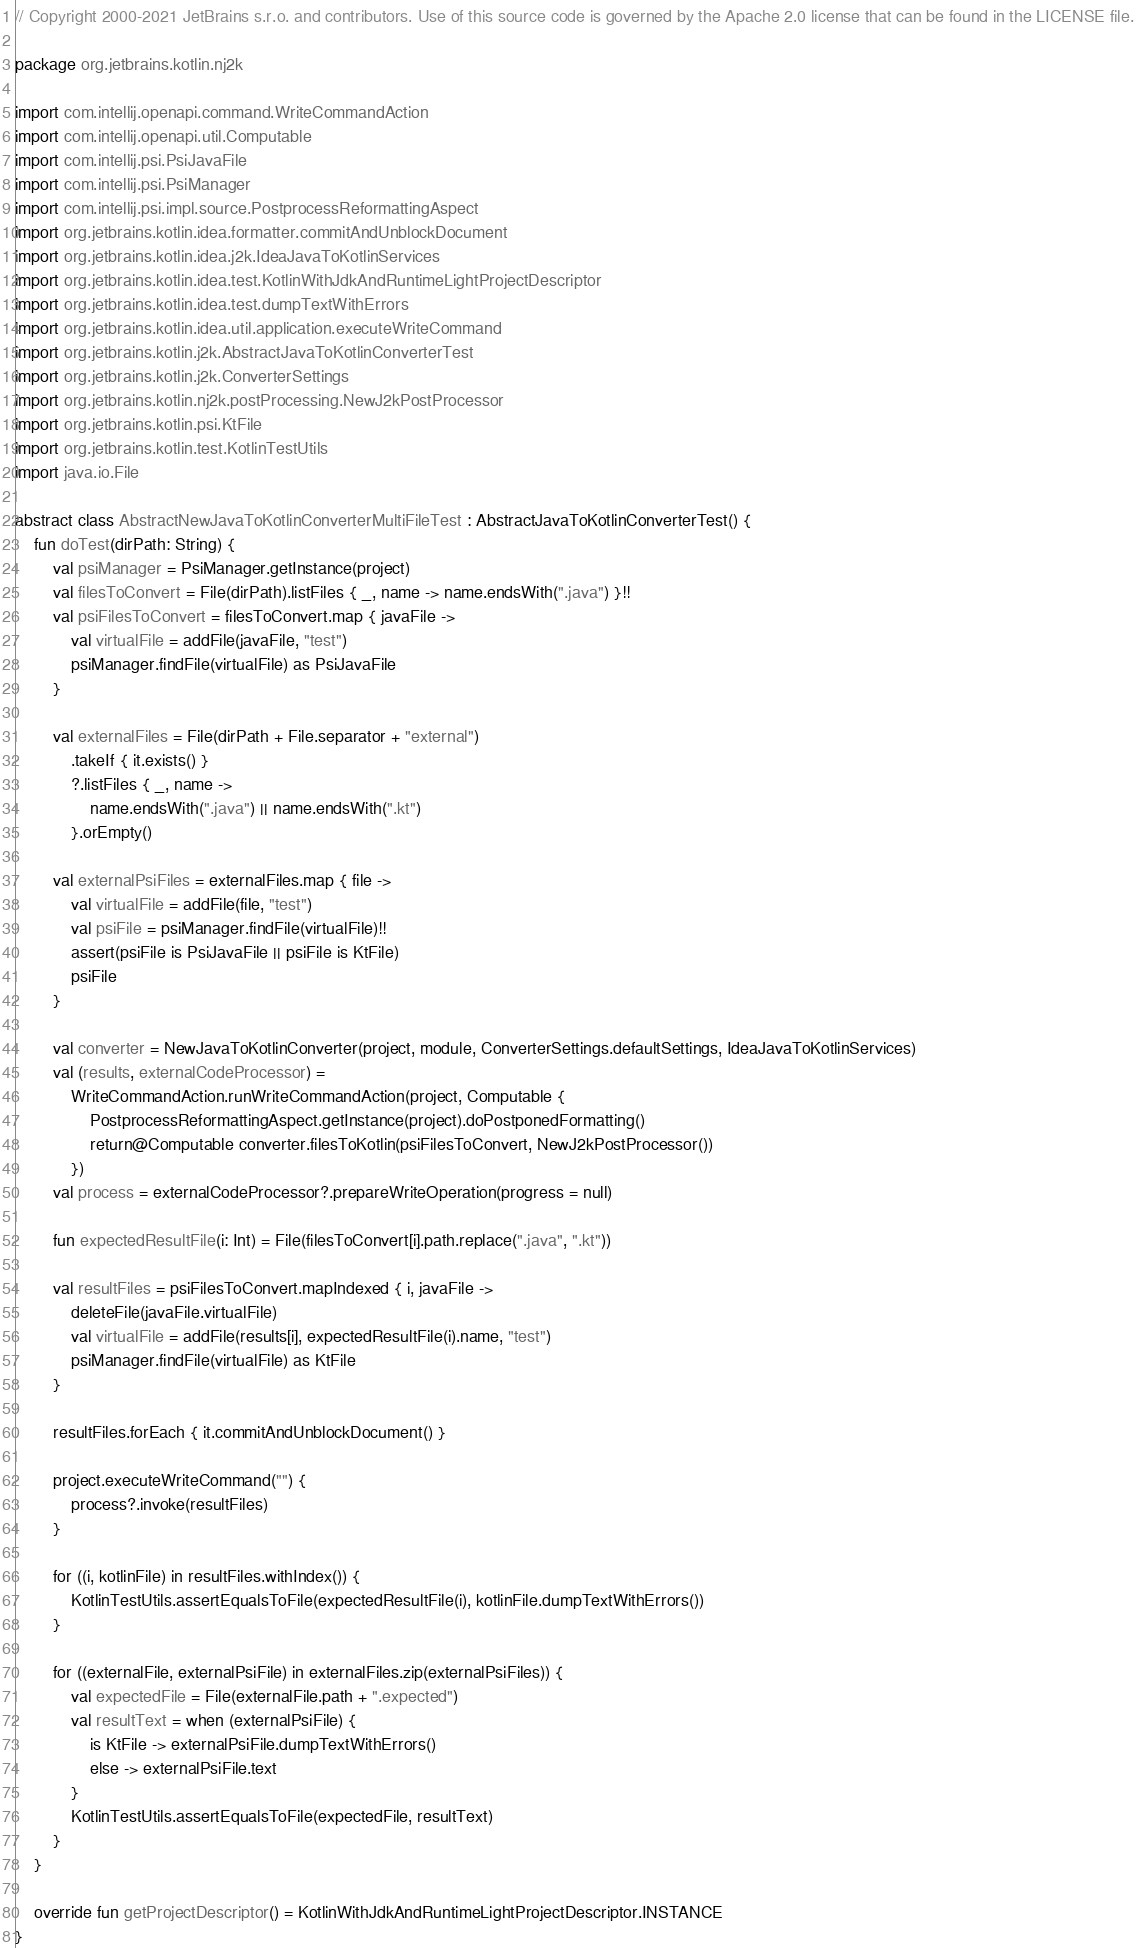Convert code to text. <code><loc_0><loc_0><loc_500><loc_500><_Kotlin_>// Copyright 2000-2021 JetBrains s.r.o. and contributors. Use of this source code is governed by the Apache 2.0 license that can be found in the LICENSE file.

package org.jetbrains.kotlin.nj2k

import com.intellij.openapi.command.WriteCommandAction
import com.intellij.openapi.util.Computable
import com.intellij.psi.PsiJavaFile
import com.intellij.psi.PsiManager
import com.intellij.psi.impl.source.PostprocessReformattingAspect
import org.jetbrains.kotlin.idea.formatter.commitAndUnblockDocument
import org.jetbrains.kotlin.idea.j2k.IdeaJavaToKotlinServices
import org.jetbrains.kotlin.idea.test.KotlinWithJdkAndRuntimeLightProjectDescriptor
import org.jetbrains.kotlin.idea.test.dumpTextWithErrors
import org.jetbrains.kotlin.idea.util.application.executeWriteCommand
import org.jetbrains.kotlin.j2k.AbstractJavaToKotlinConverterTest
import org.jetbrains.kotlin.j2k.ConverterSettings
import org.jetbrains.kotlin.nj2k.postProcessing.NewJ2kPostProcessor
import org.jetbrains.kotlin.psi.KtFile
import org.jetbrains.kotlin.test.KotlinTestUtils
import java.io.File

abstract class AbstractNewJavaToKotlinConverterMultiFileTest : AbstractJavaToKotlinConverterTest() {
    fun doTest(dirPath: String) {
        val psiManager = PsiManager.getInstance(project)
        val filesToConvert = File(dirPath).listFiles { _, name -> name.endsWith(".java") }!!
        val psiFilesToConvert = filesToConvert.map { javaFile ->
            val virtualFile = addFile(javaFile, "test")
            psiManager.findFile(virtualFile) as PsiJavaFile
        }

        val externalFiles = File(dirPath + File.separator + "external")
            .takeIf { it.exists() }
            ?.listFiles { _, name ->
                name.endsWith(".java") || name.endsWith(".kt")
            }.orEmpty()

        val externalPsiFiles = externalFiles.map { file ->
            val virtualFile = addFile(file, "test")
            val psiFile = psiManager.findFile(virtualFile)!!
            assert(psiFile is PsiJavaFile || psiFile is KtFile)
            psiFile
        }

        val converter = NewJavaToKotlinConverter(project, module, ConverterSettings.defaultSettings, IdeaJavaToKotlinServices)
        val (results, externalCodeProcessor) =
            WriteCommandAction.runWriteCommandAction(project, Computable {
                PostprocessReformattingAspect.getInstance(project).doPostponedFormatting()
                return@Computable converter.filesToKotlin(psiFilesToConvert, NewJ2kPostProcessor())
            })
        val process = externalCodeProcessor?.prepareWriteOperation(progress = null)

        fun expectedResultFile(i: Int) = File(filesToConvert[i].path.replace(".java", ".kt"))

        val resultFiles = psiFilesToConvert.mapIndexed { i, javaFile ->
            deleteFile(javaFile.virtualFile)
            val virtualFile = addFile(results[i], expectedResultFile(i).name, "test")
            psiManager.findFile(virtualFile) as KtFile
        }

        resultFiles.forEach { it.commitAndUnblockDocument() }

        project.executeWriteCommand("") {
            process?.invoke(resultFiles)
        }

        for ((i, kotlinFile) in resultFiles.withIndex()) {
            KotlinTestUtils.assertEqualsToFile(expectedResultFile(i), kotlinFile.dumpTextWithErrors())
        }

        for ((externalFile, externalPsiFile) in externalFiles.zip(externalPsiFiles)) {
            val expectedFile = File(externalFile.path + ".expected")
            val resultText = when (externalPsiFile) {
                is KtFile -> externalPsiFile.dumpTextWithErrors()
                else -> externalPsiFile.text
            }
            KotlinTestUtils.assertEqualsToFile(expectedFile, resultText)
        }
    }

    override fun getProjectDescriptor() = KotlinWithJdkAndRuntimeLightProjectDescriptor.INSTANCE
}
</code> 